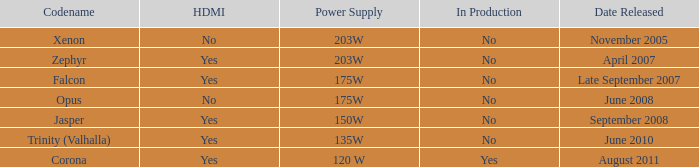Is there an hdmi feature available in trinity (valhalla)? Yes. 